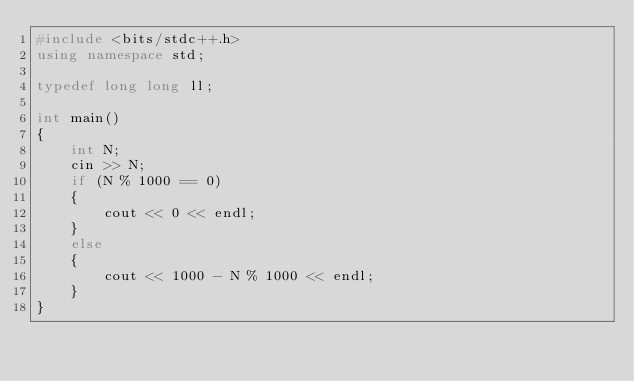<code> <loc_0><loc_0><loc_500><loc_500><_C++_>#include <bits/stdc++.h>
using namespace std;

typedef long long ll;

int main()
{
    int N;
    cin >> N;
    if (N % 1000 == 0)
    {
        cout << 0 << endl;
    }
    else
    {
        cout << 1000 - N % 1000 << endl;
    }
}</code> 